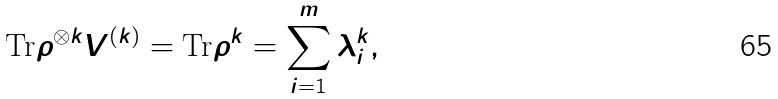Convert formula to latex. <formula><loc_0><loc_0><loc_500><loc_500>\text {Tr} \rho ^ { \otimes k } V ^ { ( k ) } = \text {Tr} \rho ^ { k } = \sum _ { i = 1 } ^ { m } \lambda _ { i } ^ { k } ,</formula> 